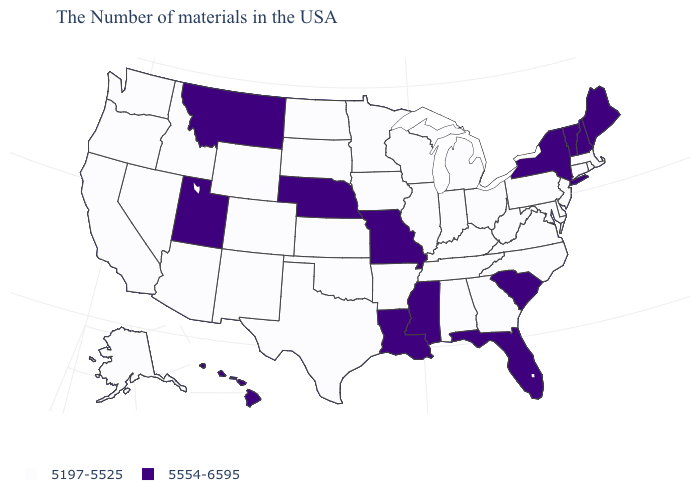Name the states that have a value in the range 5197-5525?
Short answer required. Massachusetts, Rhode Island, Connecticut, New Jersey, Delaware, Maryland, Pennsylvania, Virginia, North Carolina, West Virginia, Ohio, Georgia, Michigan, Kentucky, Indiana, Alabama, Tennessee, Wisconsin, Illinois, Arkansas, Minnesota, Iowa, Kansas, Oklahoma, Texas, South Dakota, North Dakota, Wyoming, Colorado, New Mexico, Arizona, Idaho, Nevada, California, Washington, Oregon, Alaska. How many symbols are there in the legend?
Short answer required. 2. Does Oregon have the same value as Virginia?
Write a very short answer. Yes. What is the value of Alaska?
Keep it brief. 5197-5525. Name the states that have a value in the range 5554-6595?
Give a very brief answer. Maine, New Hampshire, Vermont, New York, South Carolina, Florida, Mississippi, Louisiana, Missouri, Nebraska, Utah, Montana, Hawaii. What is the value of Nevada?
Concise answer only. 5197-5525. Name the states that have a value in the range 5197-5525?
Be succinct. Massachusetts, Rhode Island, Connecticut, New Jersey, Delaware, Maryland, Pennsylvania, Virginia, North Carolina, West Virginia, Ohio, Georgia, Michigan, Kentucky, Indiana, Alabama, Tennessee, Wisconsin, Illinois, Arkansas, Minnesota, Iowa, Kansas, Oklahoma, Texas, South Dakota, North Dakota, Wyoming, Colorado, New Mexico, Arizona, Idaho, Nevada, California, Washington, Oregon, Alaska. What is the value of Ohio?
Short answer required. 5197-5525. What is the lowest value in the USA?
Keep it brief. 5197-5525. Does the map have missing data?
Write a very short answer. No. Which states hav the highest value in the South?
Quick response, please. South Carolina, Florida, Mississippi, Louisiana. Name the states that have a value in the range 5197-5525?
Quick response, please. Massachusetts, Rhode Island, Connecticut, New Jersey, Delaware, Maryland, Pennsylvania, Virginia, North Carolina, West Virginia, Ohio, Georgia, Michigan, Kentucky, Indiana, Alabama, Tennessee, Wisconsin, Illinois, Arkansas, Minnesota, Iowa, Kansas, Oklahoma, Texas, South Dakota, North Dakota, Wyoming, Colorado, New Mexico, Arizona, Idaho, Nevada, California, Washington, Oregon, Alaska. Name the states that have a value in the range 5197-5525?
Be succinct. Massachusetts, Rhode Island, Connecticut, New Jersey, Delaware, Maryland, Pennsylvania, Virginia, North Carolina, West Virginia, Ohio, Georgia, Michigan, Kentucky, Indiana, Alabama, Tennessee, Wisconsin, Illinois, Arkansas, Minnesota, Iowa, Kansas, Oklahoma, Texas, South Dakota, North Dakota, Wyoming, Colorado, New Mexico, Arizona, Idaho, Nevada, California, Washington, Oregon, Alaska. Among the states that border Colorado , does Utah have the lowest value?
Give a very brief answer. No. 